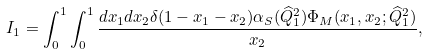Convert formula to latex. <formula><loc_0><loc_0><loc_500><loc_500>I _ { 1 } = \int _ { 0 } ^ { 1 } \int _ { 0 } ^ { 1 } \frac { d x _ { 1 } d x _ { 2 } \delta ( 1 - x _ { 1 } - x _ { 2 } ) \alpha _ { S } ( \widehat { Q } _ { 1 } ^ { 2 } ) \Phi _ { M } ( x _ { 1 } , x _ { 2 } ; \widehat { Q } _ { 1 } ^ { 2 } ) } { x _ { 2 } } ,</formula> 